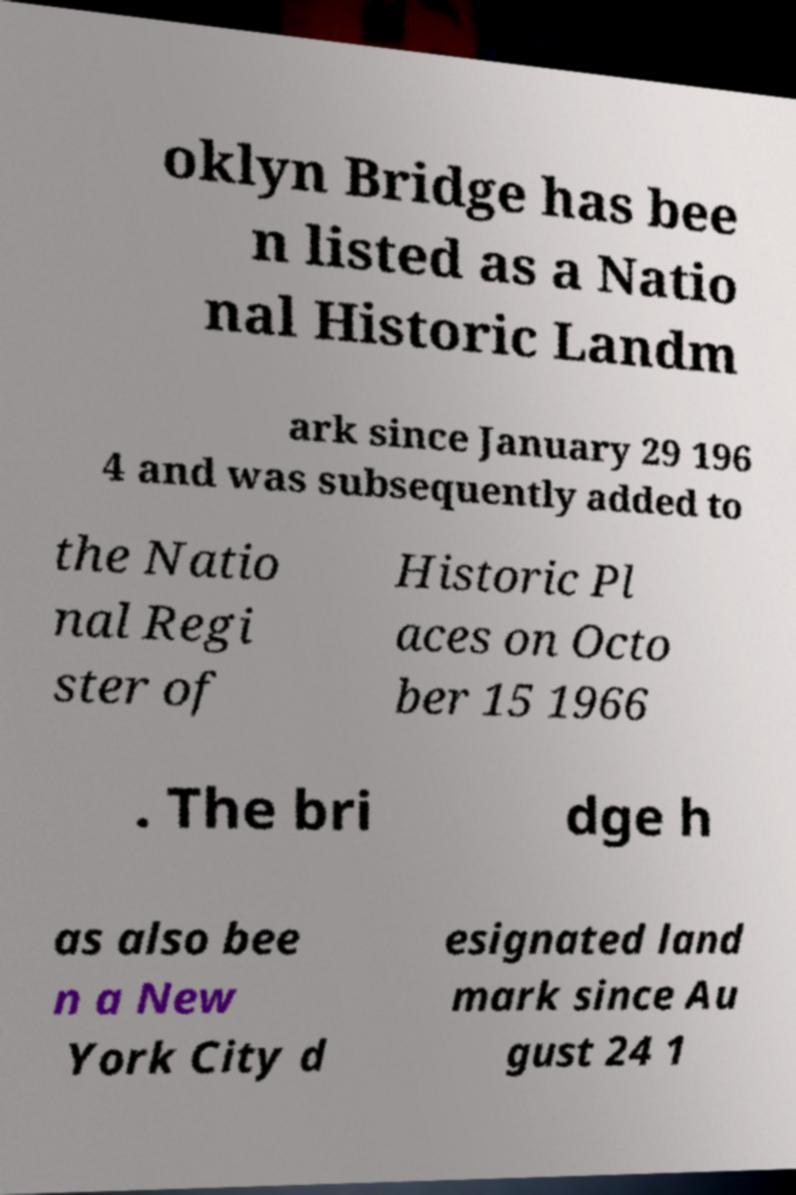Can you read and provide the text displayed in the image?This photo seems to have some interesting text. Can you extract and type it out for me? oklyn Bridge has bee n listed as a Natio nal Historic Landm ark since January 29 196 4 and was subsequently added to the Natio nal Regi ster of Historic Pl aces on Octo ber 15 1966 . The bri dge h as also bee n a New York City d esignated land mark since Au gust 24 1 